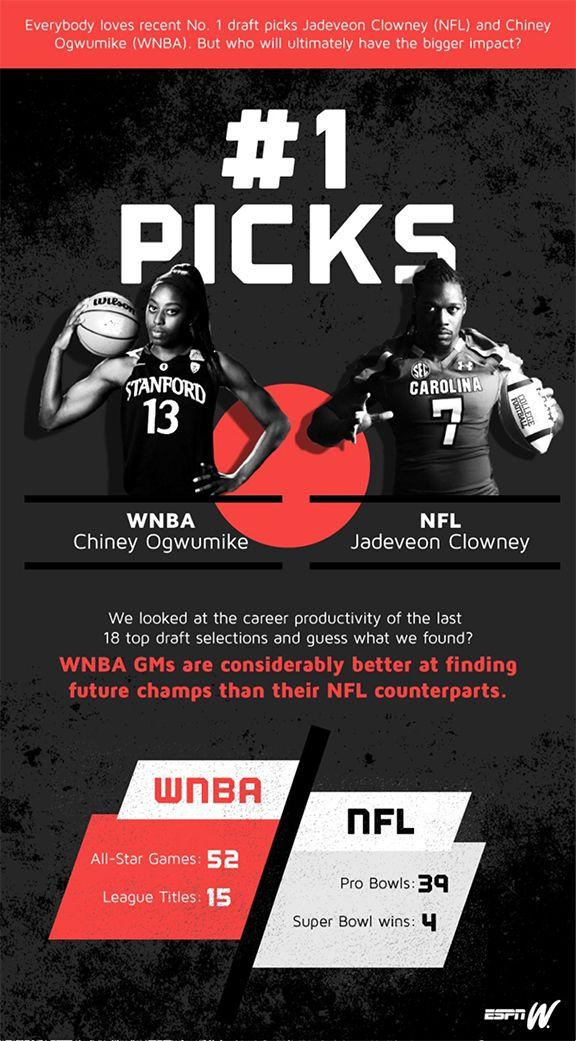Indicate a few pertinent items in this graphic. Jadeveon Clowney's jersey number is 7. I am proud to announce that I, Chiney Ogwumike, have won a total of 15 league titles in my illustrious career. Chiney Ogwumike's jersey number is 13. Jadeveon Clowney has won four Super Bowl victories in his career as a professional football player in the National Football League. 